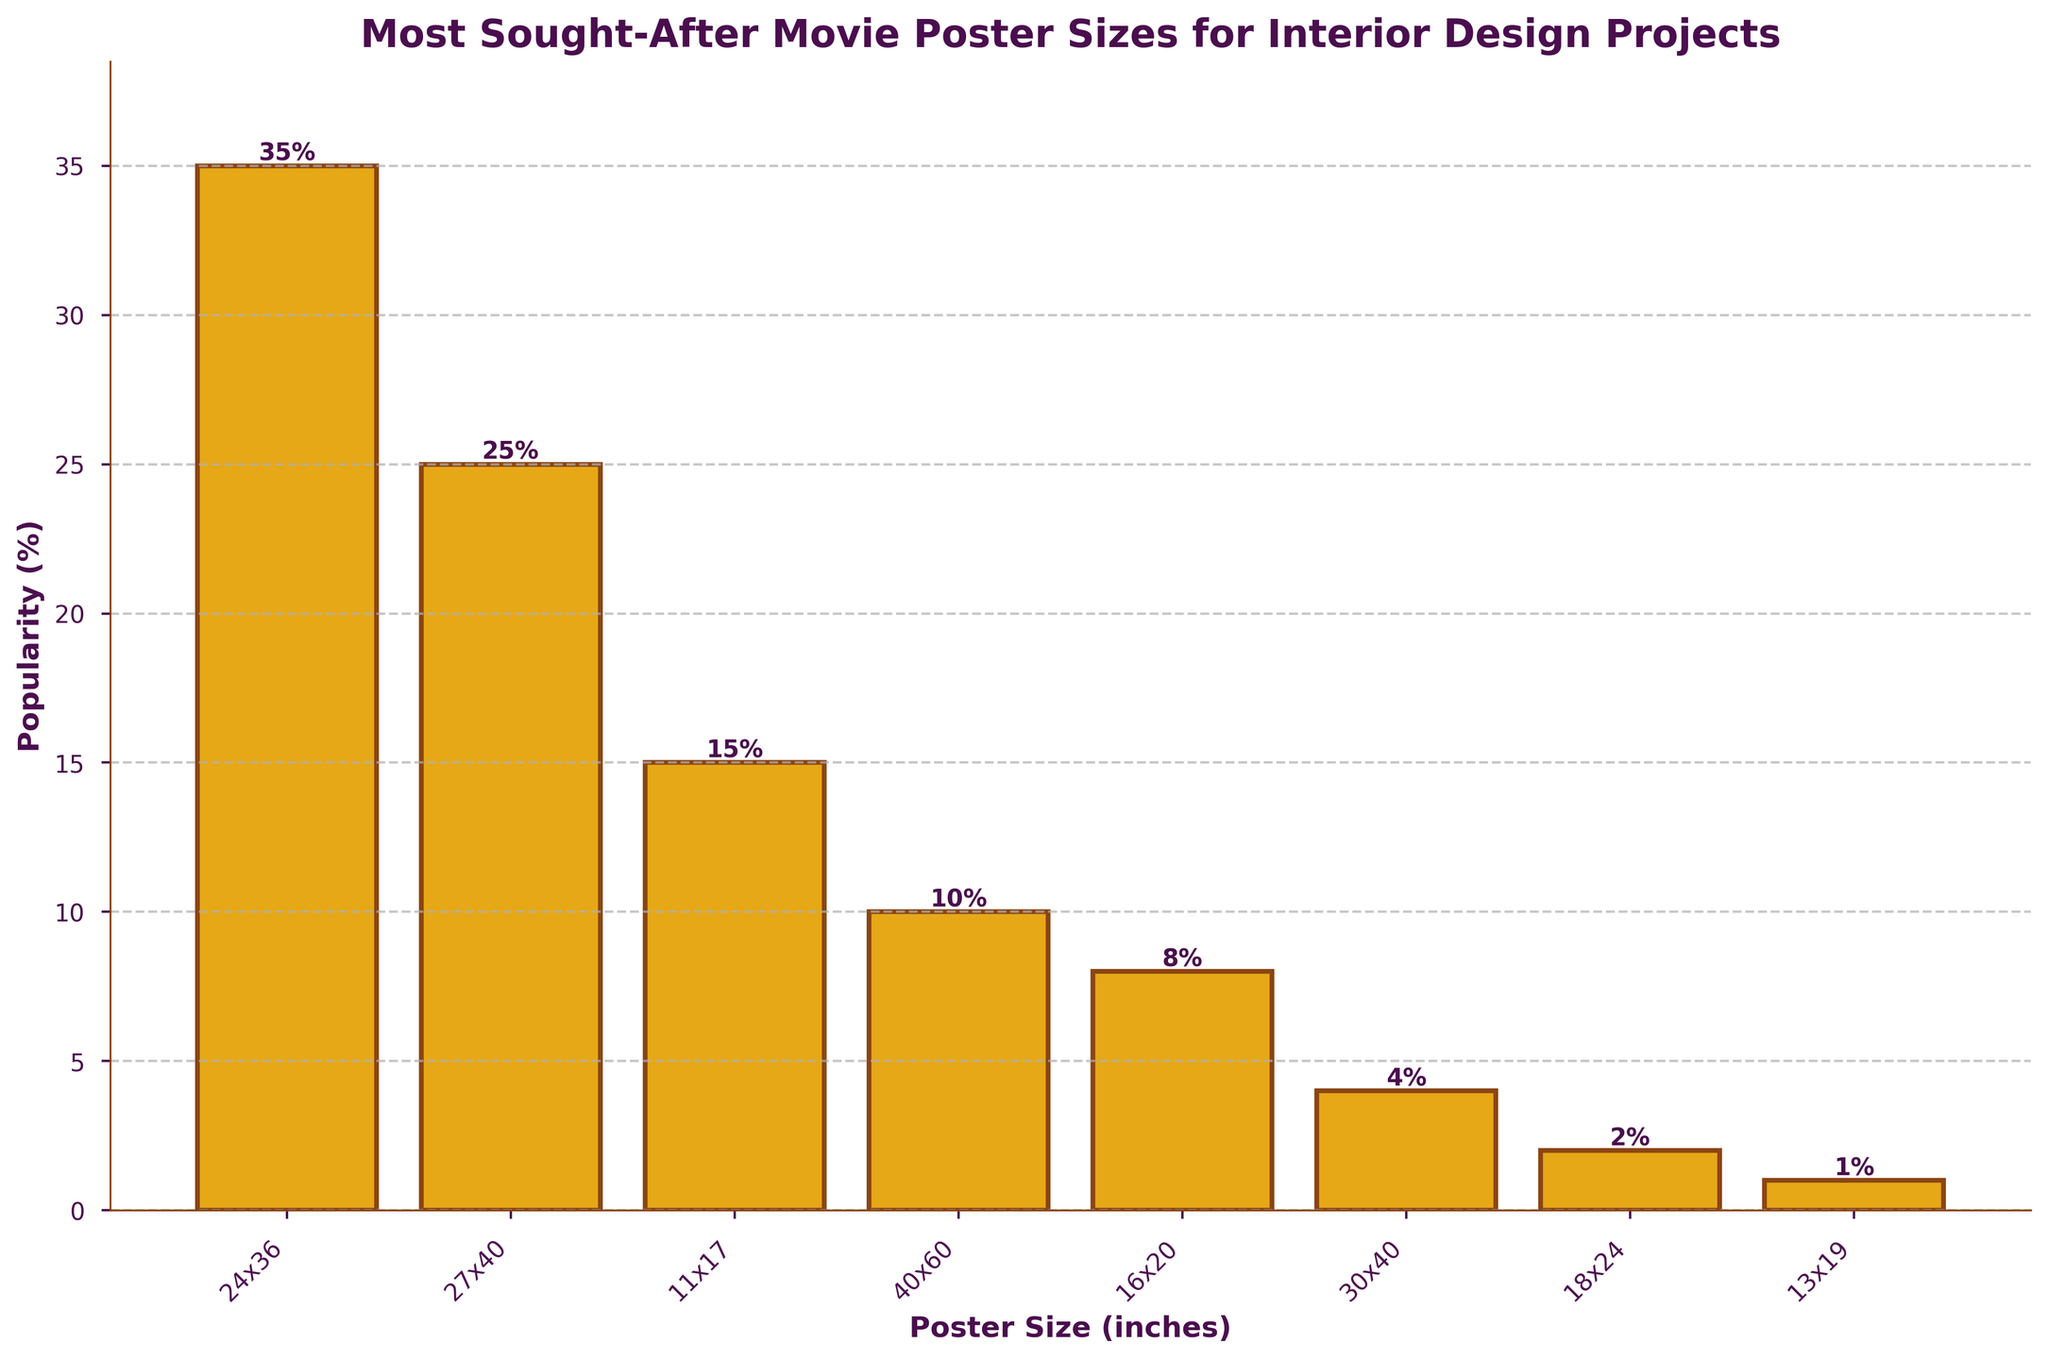Which poster size is the most popular? The bar for the 24x36 inch poster size is the tallest one, indicating it has the highest popularity percentage.
Answer: 24x36 Which two poster sizes have a combined popularity of 50%? The 24x36 inch poster has a popularity of 35% and the 27x40 inch poster has a popularity of 25%. Combining these gives 35% + 25% = 50%.
Answer: 24x36 and 27x40 Which of the following sizes is the least popular: 30x40 or 18x24? The bar for the 30x40 inch size is higher than that for the 18x24 inch size, indicating the 30x40 inch size is more popular.
Answer: 18x24 What’s the difference in popularity between the 11x17 and 40x60 inch poster sizes? The bar for the 11x17 inch size shows a popularity of 15%, and the 40x60 inch size shows 10%. The difference is 15% - 10% = 5%.
Answer: 5% Which size has a 4% popularity? The bar corresponding to the 30x40 inch size reaches the 4% mark on the y-axis.
Answer: 30x40 How many sizes have a popularity greater than or equal to 10%? The bars for the 24x36, 27x40, 11x17, and 40x60 inch sizes all have heights at or above 10%. That makes 4 sizes.
Answer: 4 Among the least popular three sizes, what is the average popularity? The least popular three sizes are 30x40 (4%), 18x24 (2%), and 13x19 (1%). Their average is (4% + 2% + 1%) / 3 = 2.33%.
Answer: 2.33% Which size is more popular: 16x20 or 13x19? The bar for the 16x20 inch size is significantly taller than that for the 13x19 inch size, indicating it's more popular.
Answer: 16x20 What percentage of poster sizes have a popularity less than 15%? There are a total of 8 sizes. The sizes with less than 15% popularity are 40x60, 16x20, 30x40, 18x24, and 13x19, making 5 sizes. The percentage is (5/8) * 100 = 62.5%.
Answer: 62.5% What is the popularity difference between the most and least popular poster sizes? The most popular size is 24x36 with 35% popularity, and the least is 13x19 with 1% popularity. The difference is 35% - 1% = 34%.
Answer: 34% 